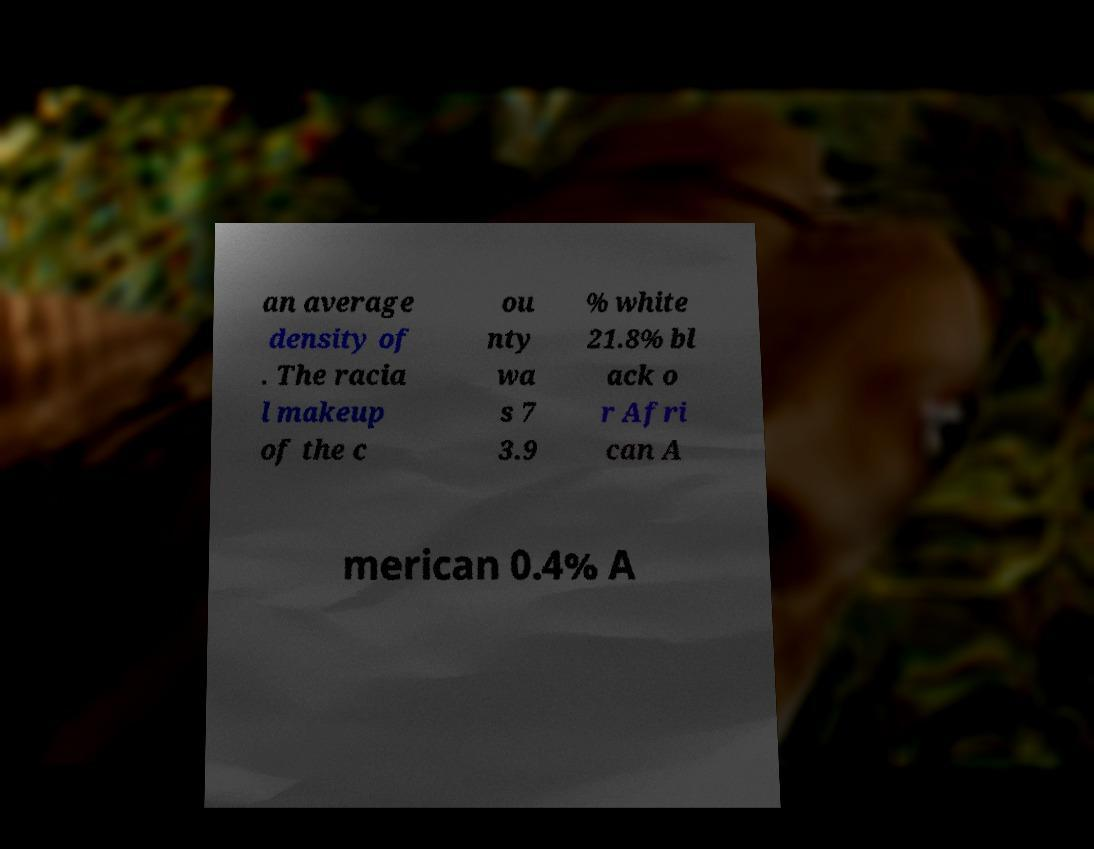Please identify and transcribe the text found in this image. an average density of . The racia l makeup of the c ou nty wa s 7 3.9 % white 21.8% bl ack o r Afri can A merican 0.4% A 